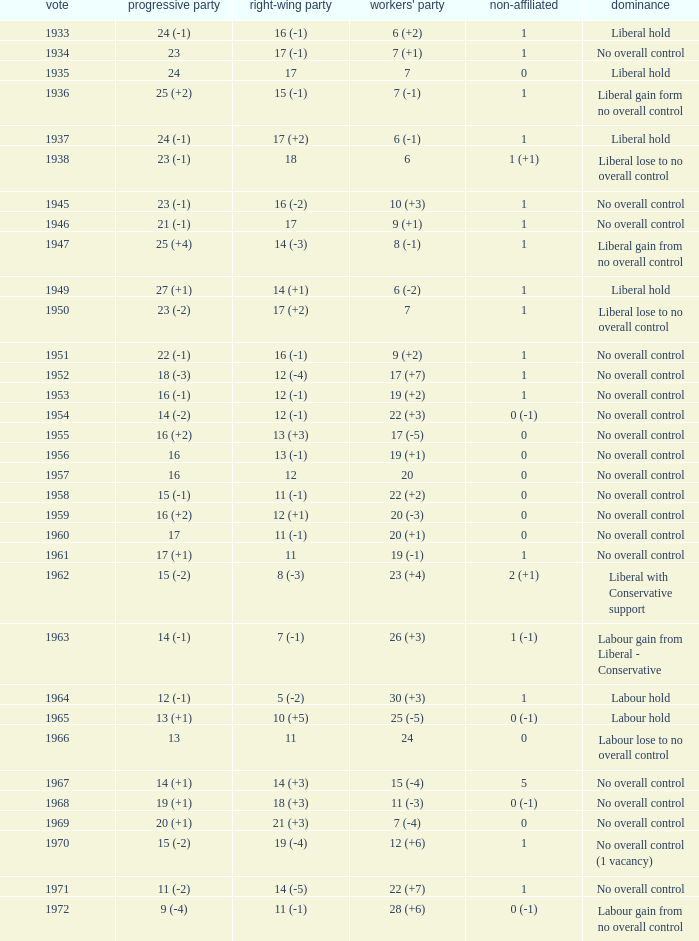What was the Liberal Party result from the election having a Conservative Party result of 16 (-1) and Labour of 6 (+2)? 24 (-1). 